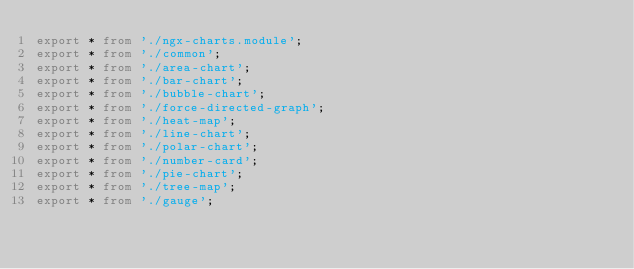Convert code to text. <code><loc_0><loc_0><loc_500><loc_500><_TypeScript_>export * from './ngx-charts.module';
export * from './common';
export * from './area-chart';
export * from './bar-chart';
export * from './bubble-chart';
export * from './force-directed-graph';
export * from './heat-map';
export * from './line-chart';
export * from './polar-chart';
export * from './number-card';
export * from './pie-chart';
export * from './tree-map';
export * from './gauge';
</code> 